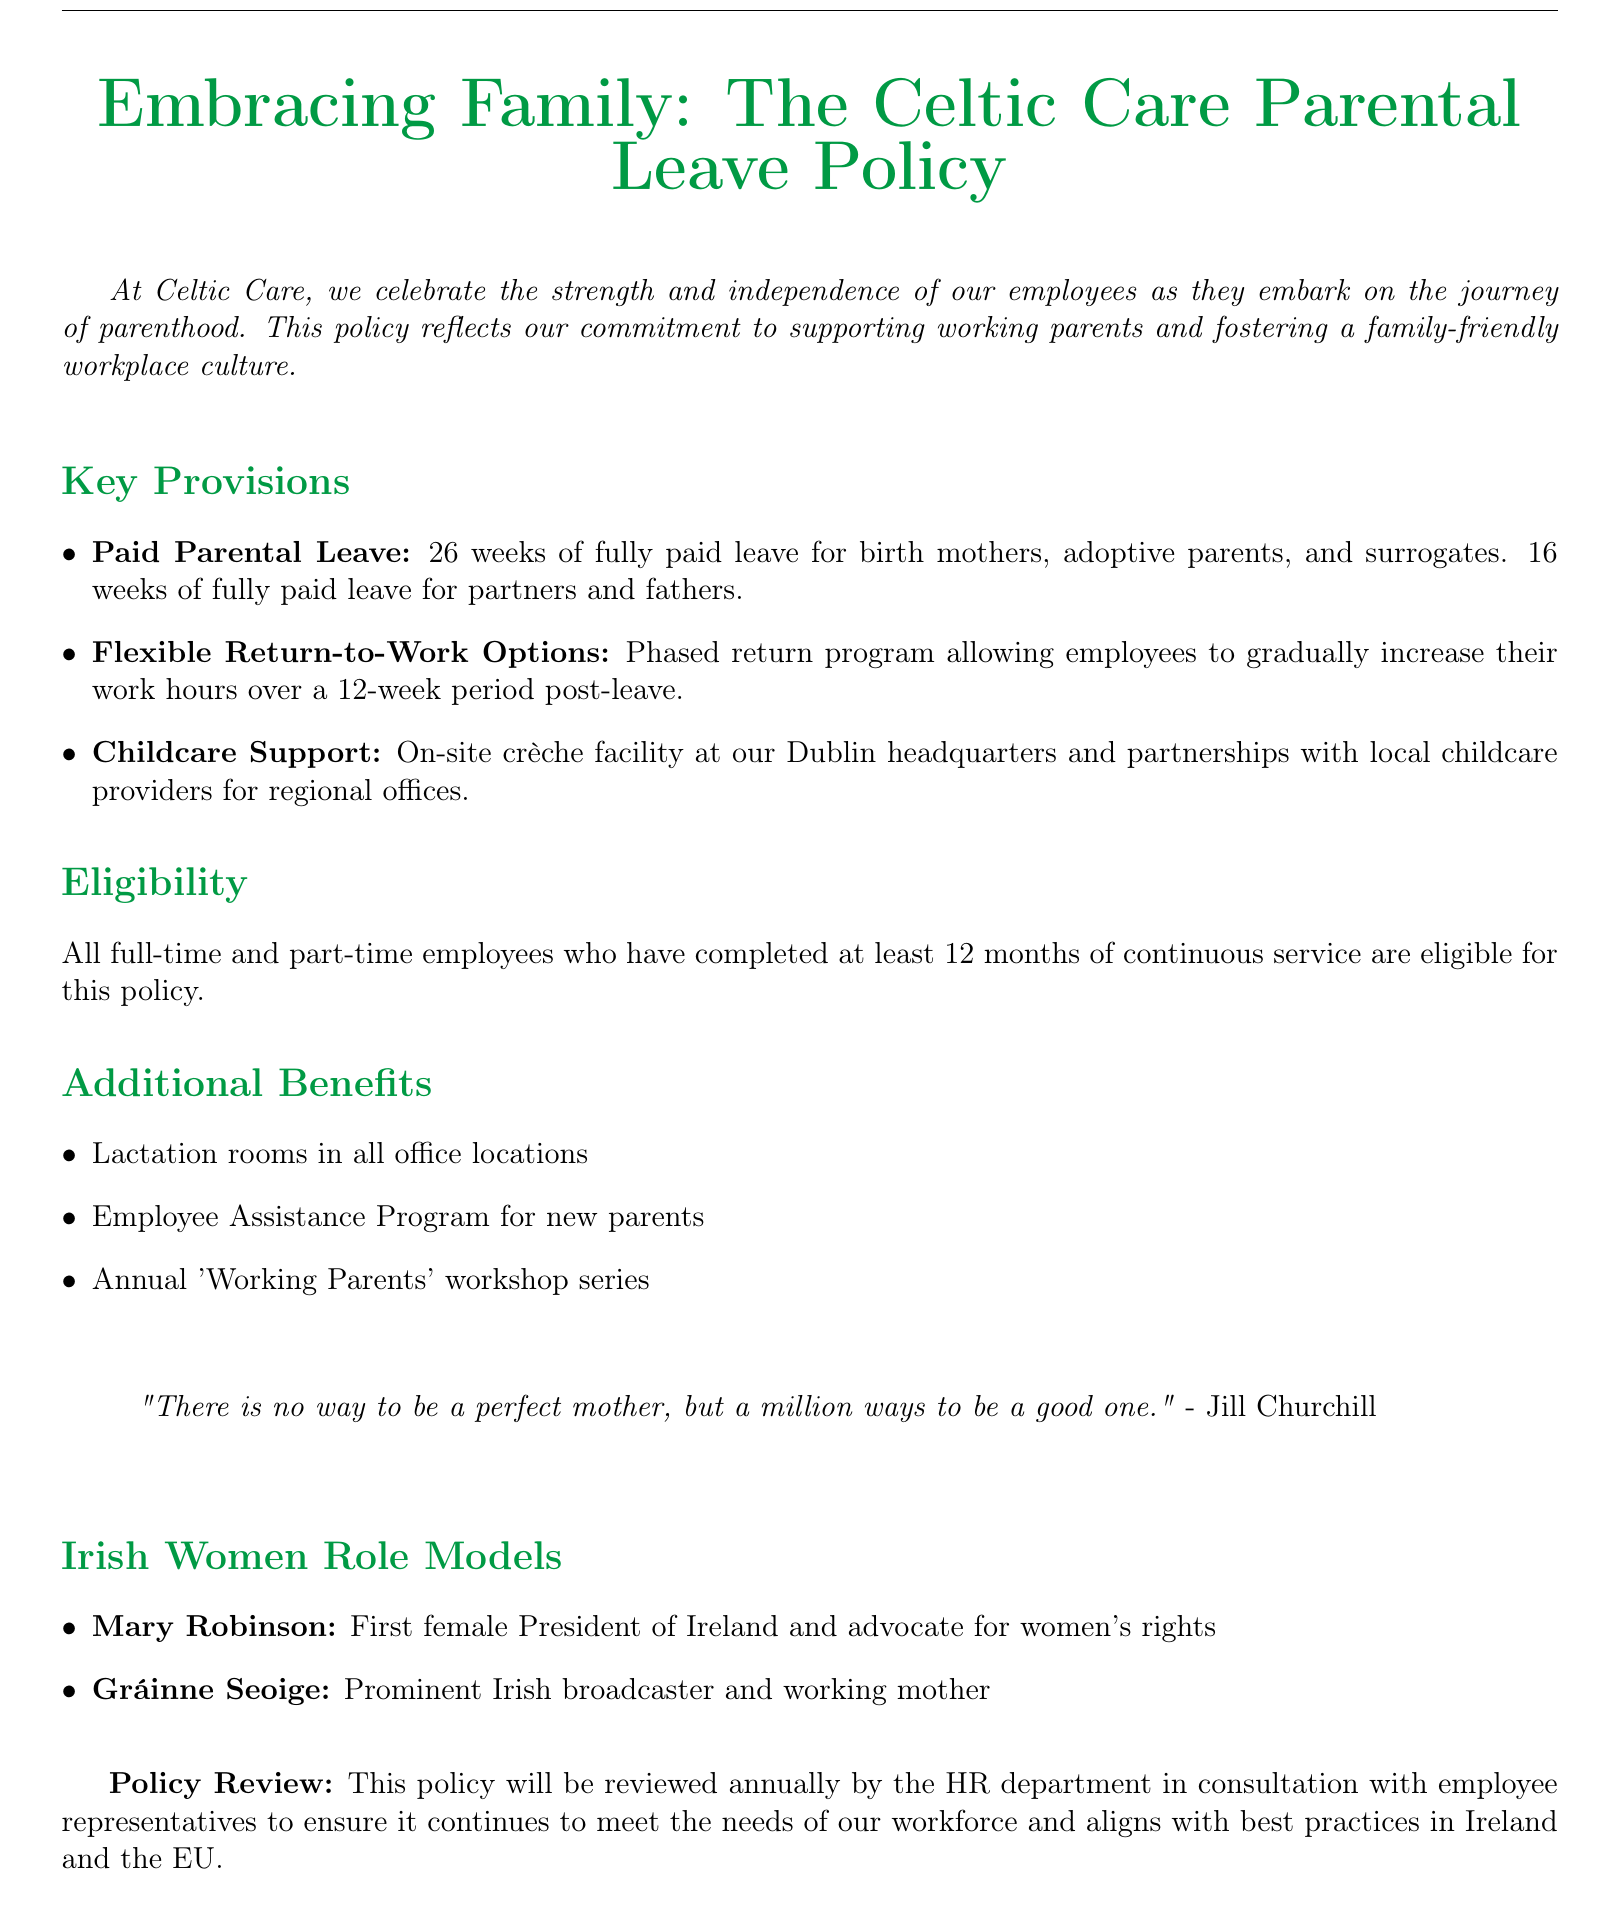What is the duration of fully paid leave for birth mothers? The document states that birth mothers receive 26 weeks of fully paid leave.
Answer: 26 weeks How many weeks of paid leave do partners receive? The document specifies that partners and fathers receive 16 weeks of fully paid leave.
Answer: 16 weeks What type of childcare support is available at the Dublin headquarters? The document mentions an on-site crèche facility available at the Dublin headquarters.
Answer: On-site crèche facility Who is eligible for the parental leave policy? The policy is available to all full-time and part-time employees who have completed at least 12 months of continuous service.
Answer: 12 months What is one additional benefit mentioned in the policy? The document lists lactation rooms in all office locations as one of the additional benefits.
Answer: Lactation rooms What does the phased return program allow employees to do? The phased return program enables employees to gradually increase their work hours over a 12-week period post-leave.
Answer: Gradually increase work hours What is the purpose of the annual policy review? The policy review aims to ensure it continues to meet the needs of the workforce and aligns with best practices.
Answer: Meet workforce needs Who is one of the Irish women role models mentioned in the document? The document mentions Mary Robinson as one of the Irish women role models.
Answer: Mary Robinson Which program is offered for new parents beyond parental leave? The document includes an Employee Assistance Program for new parents as an additional benefit.
Answer: Employee Assistance Program 